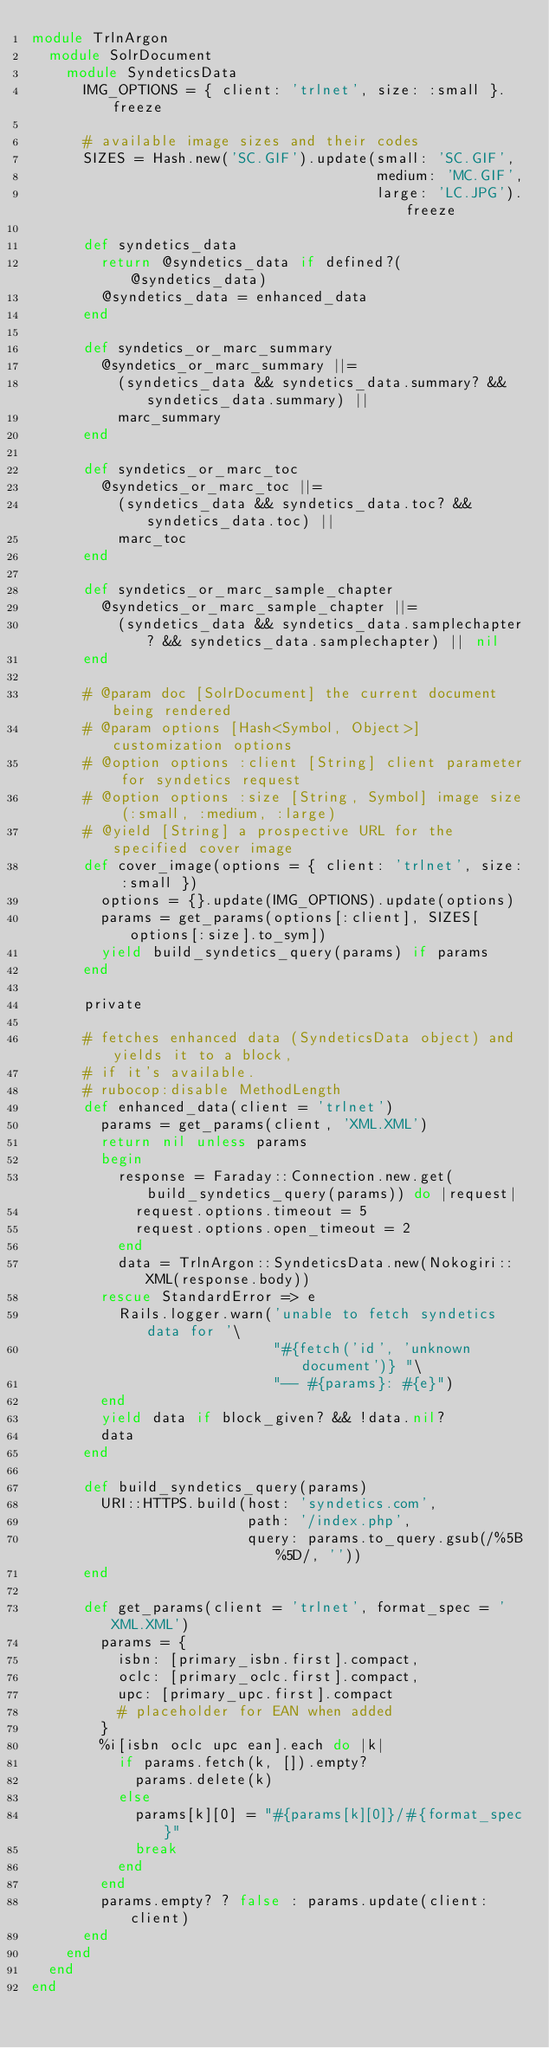<code> <loc_0><loc_0><loc_500><loc_500><_Ruby_>module TrlnArgon
  module SolrDocument
    module SyndeticsData
      IMG_OPTIONS = { client: 'trlnet', size: :small }.freeze

      # available image sizes and their codes
      SIZES = Hash.new('SC.GIF').update(small: 'SC.GIF',
                                        medium: 'MC.GIF',
                                        large: 'LC.JPG').freeze

      def syndetics_data
        return @syndetics_data if defined?(@syndetics_data)
        @syndetics_data = enhanced_data
      end

      def syndetics_or_marc_summary
        @syndetics_or_marc_summary ||=
          (syndetics_data && syndetics_data.summary? && syndetics_data.summary) ||
          marc_summary
      end

      def syndetics_or_marc_toc
        @syndetics_or_marc_toc ||=
          (syndetics_data && syndetics_data.toc? && syndetics_data.toc) ||
          marc_toc
      end

      def syndetics_or_marc_sample_chapter
        @syndetics_or_marc_sample_chapter ||=
          (syndetics_data && syndetics_data.samplechapter? && syndetics_data.samplechapter) || nil
      end

      # @param doc [SolrDocument] the current document being rendered
      # @param options [Hash<Symbol, Object>] customization options
      # @option options :client [String] client parameter for syndetics request
      # @option options :size [String, Symbol] image size (:small, :medium, :large)
      # @yield [String] a prospective URL for the specified cover image
      def cover_image(options = { client: 'trlnet', size: :small })
        options = {}.update(IMG_OPTIONS).update(options)
        params = get_params(options[:client], SIZES[options[:size].to_sym])
        yield build_syndetics_query(params) if params
      end

      private

      # fetches enhanced data (SyndeticsData object) and yields it to a block,
      # if it's available.
      # rubocop:disable MethodLength
      def enhanced_data(client = 'trlnet')
        params = get_params(client, 'XML.XML')
        return nil unless params
        begin
          response = Faraday::Connection.new.get(build_syndetics_query(params)) do |request|
            request.options.timeout = 5
            request.options.open_timeout = 2
          end
          data = TrlnArgon::SyndeticsData.new(Nokogiri::XML(response.body))
        rescue StandardError => e
          Rails.logger.warn('unable to fetch syndetics data for '\
                            "#{fetch('id', 'unknown document')} "\
                            "-- #{params}: #{e}")
        end
        yield data if block_given? && !data.nil?
        data
      end

      def build_syndetics_query(params)
        URI::HTTPS.build(host: 'syndetics.com',
                         path: '/index.php',
                         query: params.to_query.gsub(/%5B%5D/, ''))
      end

      def get_params(client = 'trlnet', format_spec = 'XML.XML')
        params = {
          isbn: [primary_isbn.first].compact,
          oclc: [primary_oclc.first].compact,
          upc: [primary_upc.first].compact
          # placeholder for EAN when added
        }
        %i[isbn oclc upc ean].each do |k|
          if params.fetch(k, []).empty?
            params.delete(k)
          else
            params[k][0] = "#{params[k][0]}/#{format_spec}"
            break
          end
        end
        params.empty? ? false : params.update(client: client)
      end
    end
  end
end
</code> 